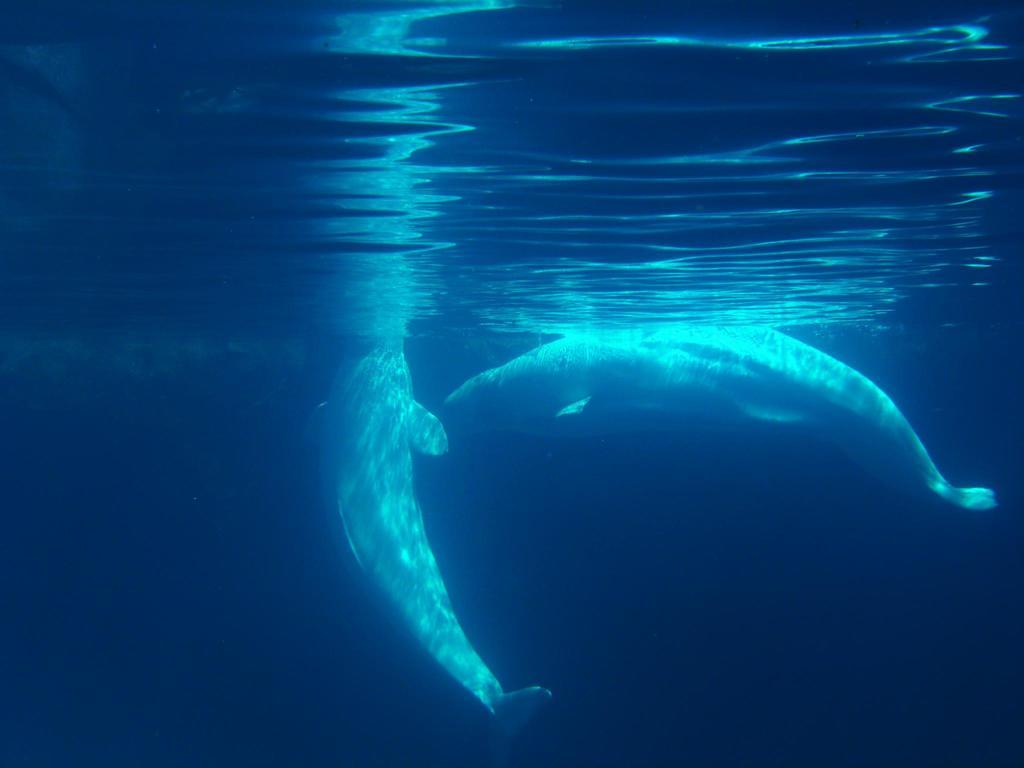How many dolphins are in the image? There are two dolphins in the image. Where are the dolphins located in the image? The dolphins are in the water. What is the size of the dolphins in the image? The size of the dolphins cannot be determined from the image alone, as it does not provide a reference for scale. What type of scene is depicted in the image? The image depicts a scene with two dolphins in the water. In what year was the image taken? The provided facts do not include information about the year the image was taken. 